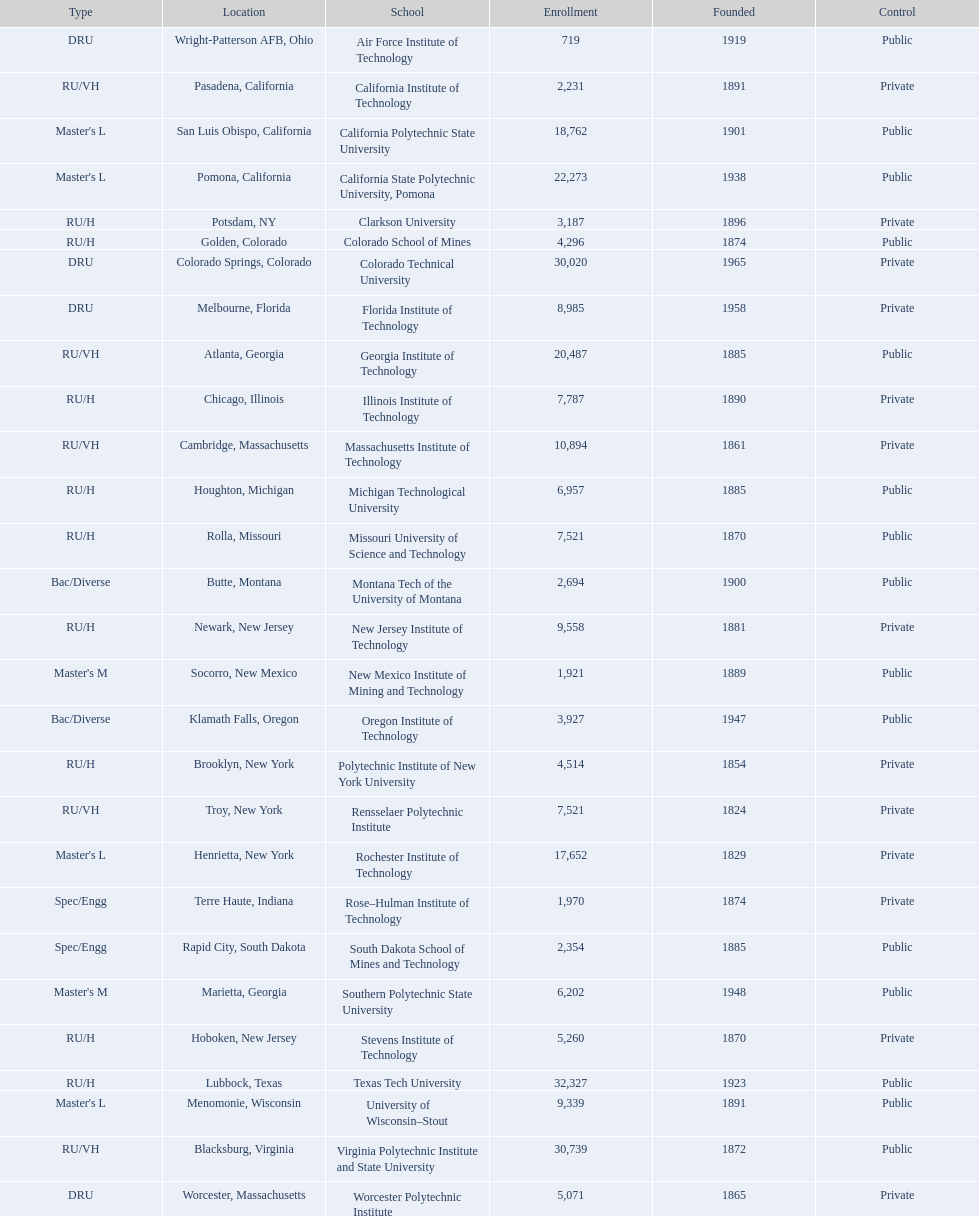What technical universities are in the united states? Air Force Institute of Technology, California Institute of Technology, California Polytechnic State University, California State Polytechnic University, Pomona, Clarkson University, Colorado School of Mines, Colorado Technical University, Florida Institute of Technology, Georgia Institute of Technology, Illinois Institute of Technology, Massachusetts Institute of Technology, Michigan Technological University, Missouri University of Science and Technology, Montana Tech of the University of Montana, New Jersey Institute of Technology, New Mexico Institute of Mining and Technology, Oregon Institute of Technology, Polytechnic Institute of New York University, Rensselaer Polytechnic Institute, Rochester Institute of Technology, Rose–Hulman Institute of Technology, South Dakota School of Mines and Technology, Southern Polytechnic State University, Stevens Institute of Technology, Texas Tech University, University of Wisconsin–Stout, Virginia Polytechnic Institute and State University, Worcester Polytechnic Institute. Which has the highest enrollment? Texas Tech University. 